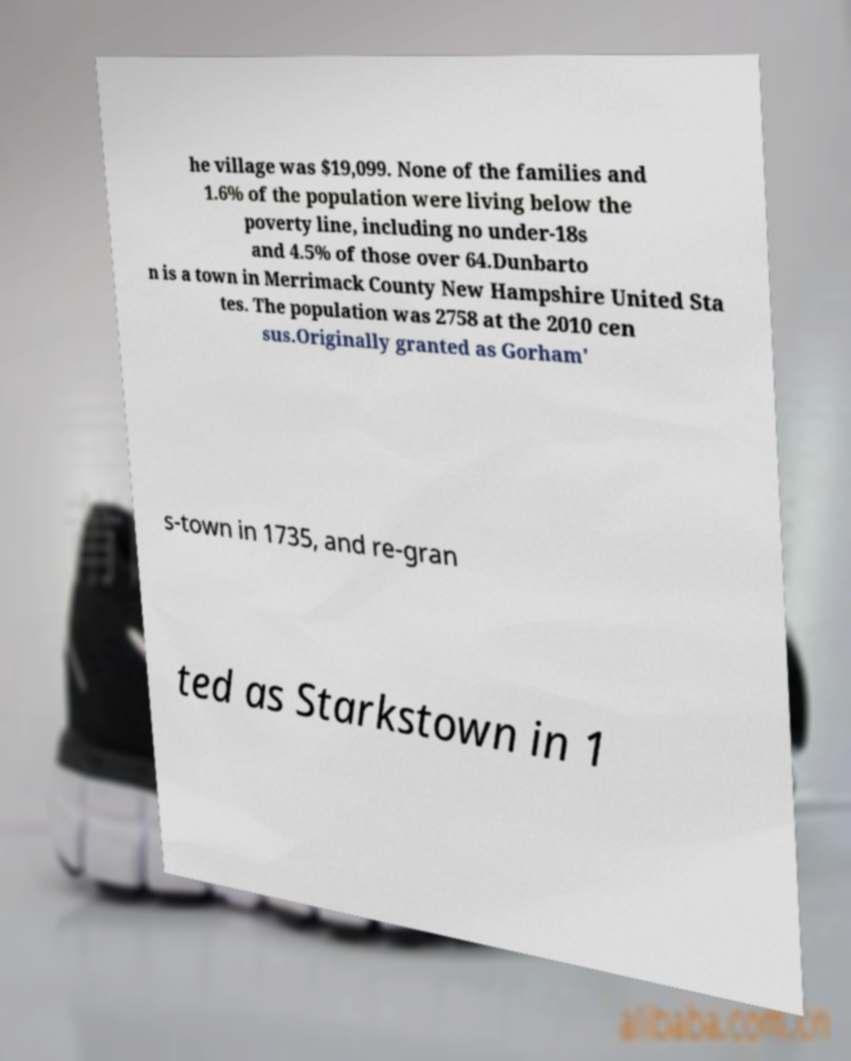Could you extract and type out the text from this image? he village was $19,099. None of the families and 1.6% of the population were living below the poverty line, including no under-18s and 4.5% of those over 64.Dunbarto n is a town in Merrimack County New Hampshire United Sta tes. The population was 2758 at the 2010 cen sus.Originally granted as Gorham' s-town in 1735, and re-gran ted as Starkstown in 1 